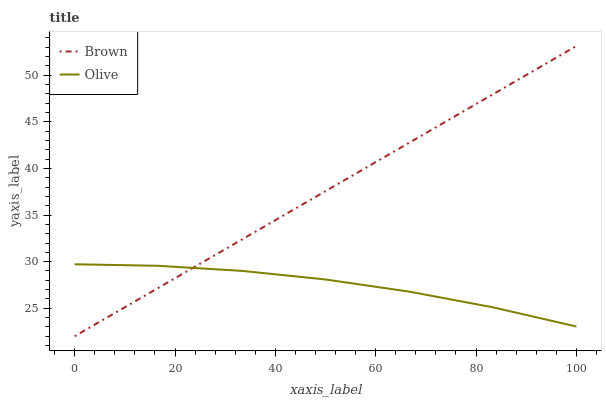Does Olive have the minimum area under the curve?
Answer yes or no. Yes. Does Brown have the maximum area under the curve?
Answer yes or no. Yes. Does Brown have the minimum area under the curve?
Answer yes or no. No. Is Brown the smoothest?
Answer yes or no. Yes. Is Olive the roughest?
Answer yes or no. Yes. Is Brown the roughest?
Answer yes or no. No. Does Brown have the lowest value?
Answer yes or no. Yes. Does Brown have the highest value?
Answer yes or no. Yes. Does Olive intersect Brown?
Answer yes or no. Yes. Is Olive less than Brown?
Answer yes or no. No. Is Olive greater than Brown?
Answer yes or no. No. 